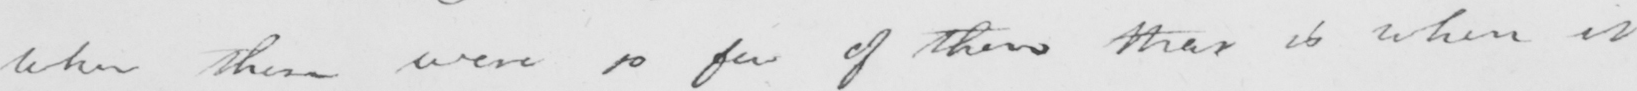Can you read and transcribe this handwriting? when there were so few of these that is when it 